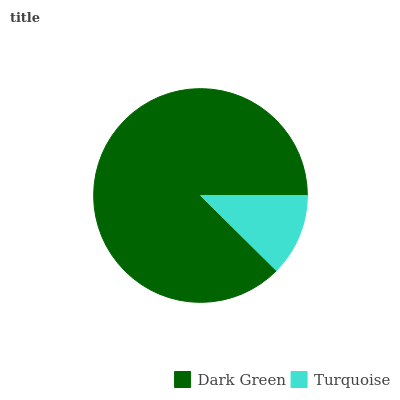Is Turquoise the minimum?
Answer yes or no. Yes. Is Dark Green the maximum?
Answer yes or no. Yes. Is Turquoise the maximum?
Answer yes or no. No. Is Dark Green greater than Turquoise?
Answer yes or no. Yes. Is Turquoise less than Dark Green?
Answer yes or no. Yes. Is Turquoise greater than Dark Green?
Answer yes or no. No. Is Dark Green less than Turquoise?
Answer yes or no. No. Is Dark Green the high median?
Answer yes or no. Yes. Is Turquoise the low median?
Answer yes or no. Yes. Is Turquoise the high median?
Answer yes or no. No. Is Dark Green the low median?
Answer yes or no. No. 